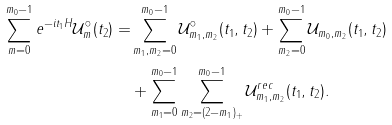Convert formula to latex. <formula><loc_0><loc_0><loc_500><loc_500>\sum _ { m = 0 } ^ { m _ { 0 } - 1 } e ^ { - i t _ { 1 } H } \mathcal { U } _ { m } ^ { \circ } ( t _ { 2 } ) = & \sum _ { m _ { 1 } , m _ { 2 } = 0 } ^ { m _ { 0 } - 1 } \mathcal { U } ^ { \circ } _ { m _ { 1 } , m _ { 2 } } ( t _ { 1 } , t _ { 2 } ) + \sum _ { m _ { 2 } = 0 } ^ { m _ { 0 } - 1 } \mathcal { U } _ { m _ { 0 } , m _ { 2 } } ( t _ { 1 } , t _ { 2 } ) \\ & + \sum _ { m _ { 1 } = 0 } ^ { m _ { 0 } - 1 } \sum _ { m _ { 2 } = ( 2 - m _ { 1 } ) _ { + } } ^ { m _ { 0 } - 1 } \mathcal { U } ^ { r e c } _ { m _ { 1 } , m _ { 2 } } ( t _ { 1 } , t _ { 2 } ) .</formula> 